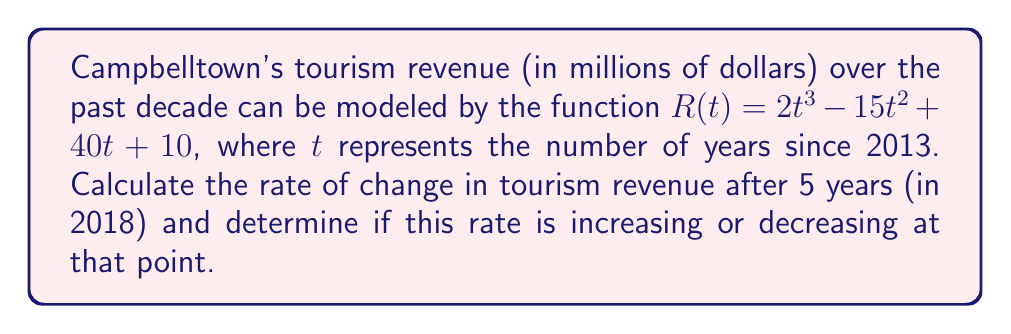Can you answer this question? To solve this problem, we need to follow these steps:

1) First, we need to find the rate of change of the revenue function. This is given by the first derivative of $R(t)$:

   $$R'(t) = 6t^2 - 30t + 40$$

2) To find the rate of change after 5 years, we substitute $t=5$ into $R'(t)$:

   $$R'(5) = 6(5)^2 - 30(5) + 40 = 150 - 150 + 40 = 40$$

3) To determine if this rate is increasing or decreasing, we need to find the second derivative of $R(t)$ and evaluate it at $t=5$:

   $$R''(t) = 12t - 30$$
   $$R''(5) = 12(5) - 30 = 60 - 30 = 30$$

4) Since $R''(5)$ is positive, the rate of change is increasing at $t=5$.

Therefore, after 5 years (in 2018), the tourism revenue in Campbelltown was changing at a rate of 40 million dollars per year, and this rate was increasing.
Answer: 40 million dollars per year, increasing 